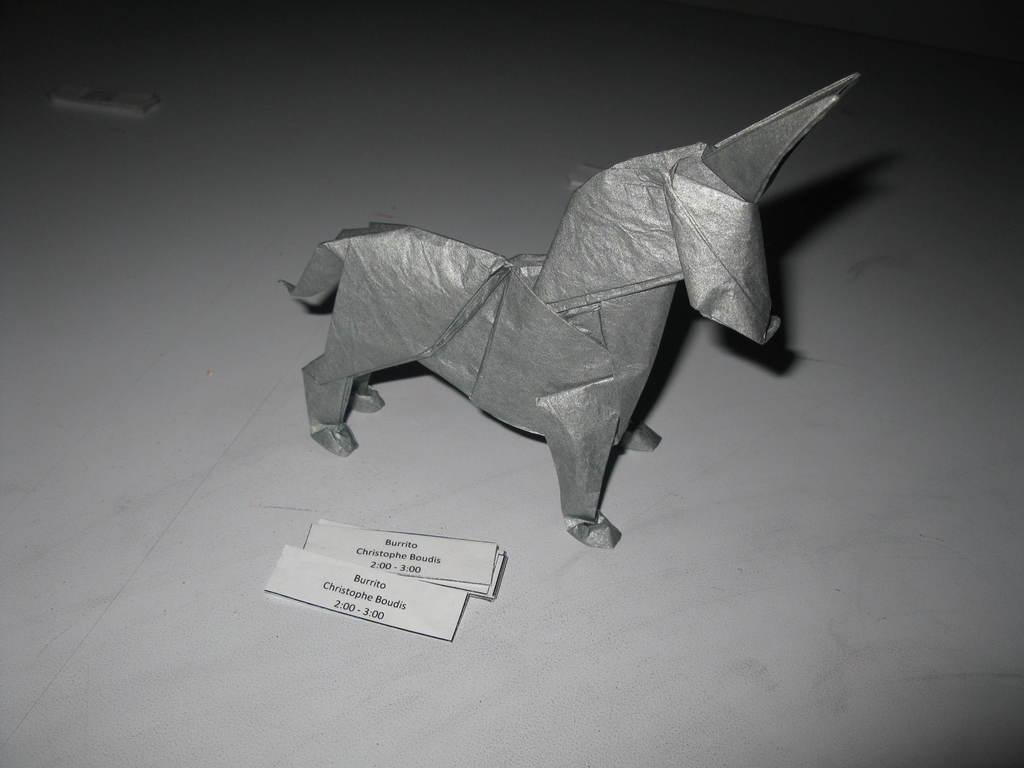Can you describe this image briefly? In this image, we can see a paper horse. There are labels at the bottom of the image. 